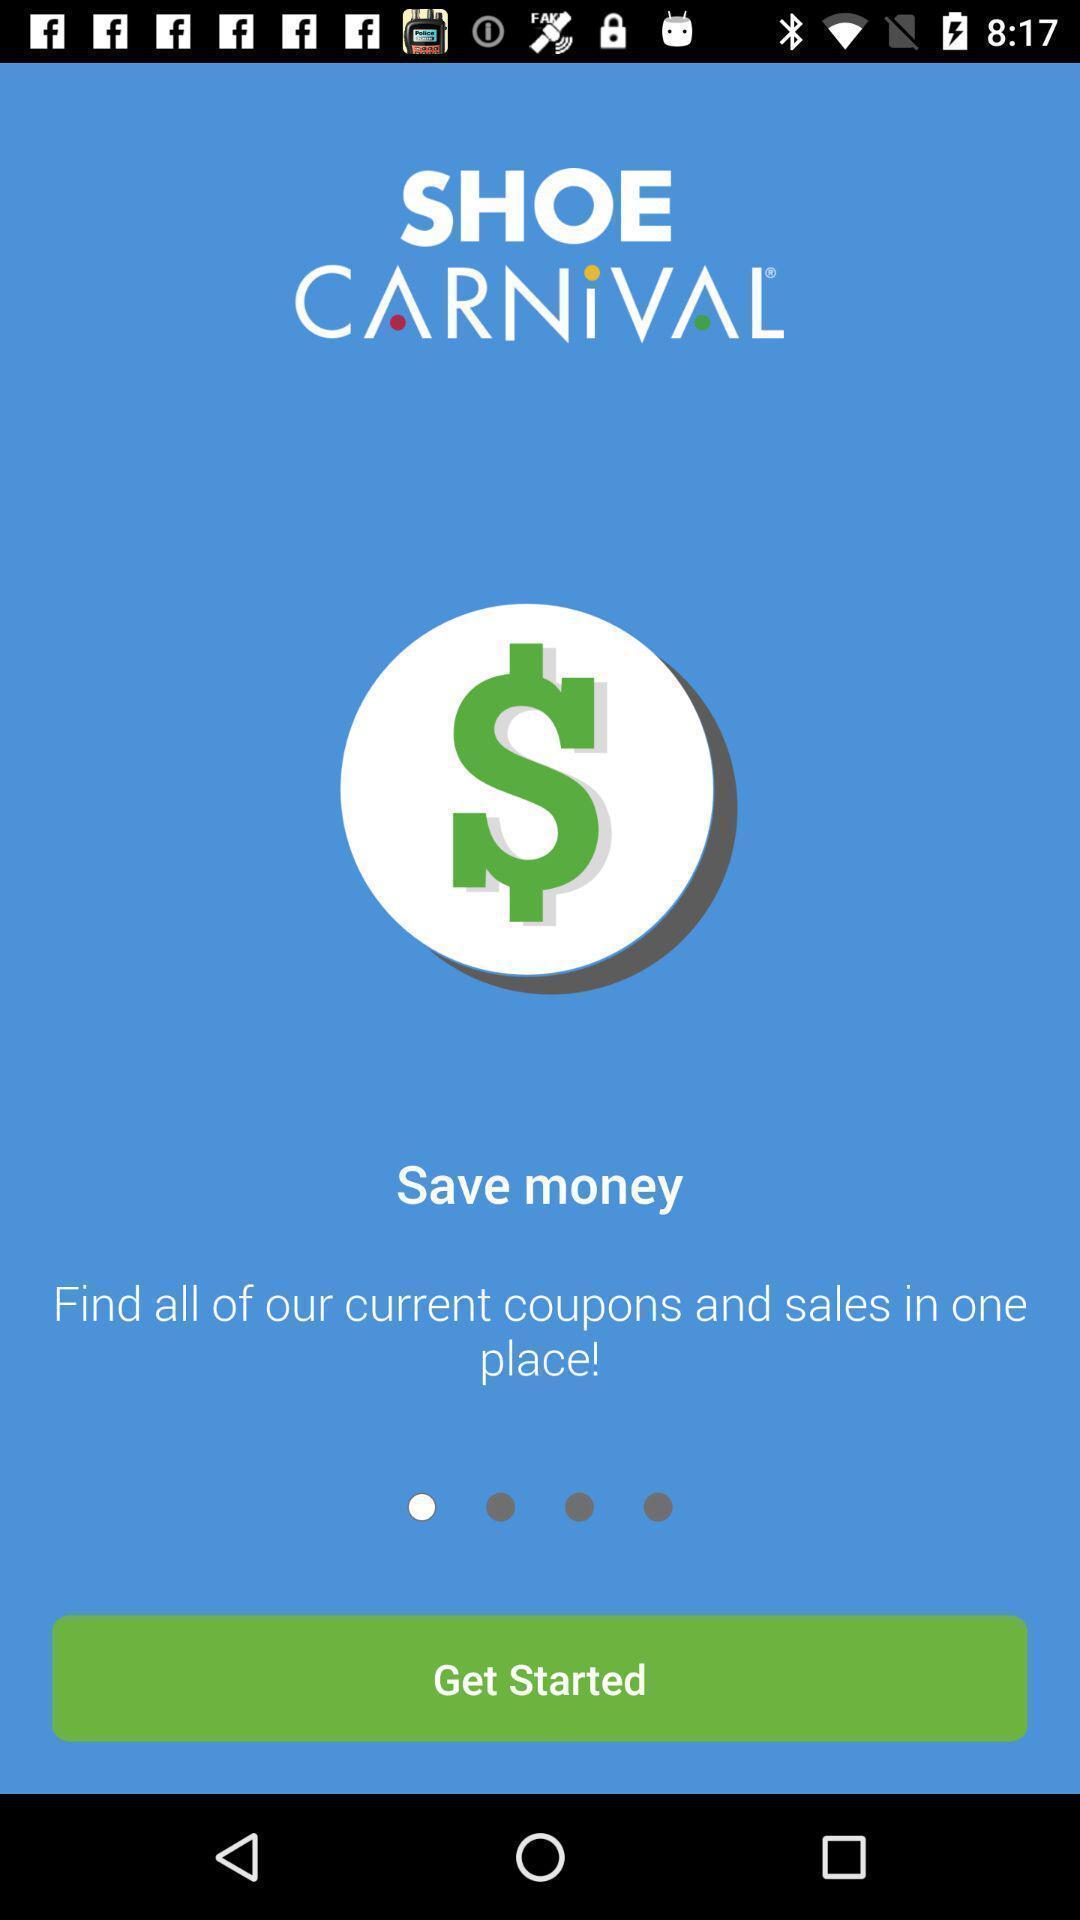Describe the content in this image. Welcome page with get started option. 